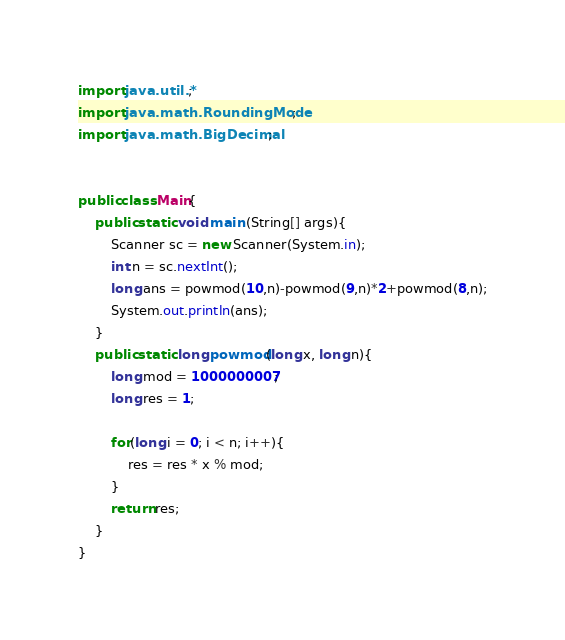Convert code to text. <code><loc_0><loc_0><loc_500><loc_500><_Java_>import java.util.*;
import java.math.RoundingMode;
import java.math.BigDecimal;
 
 
public class Main{
	public static void main (String[] args){
		Scanner sc = new Scanner(System.in);
		int n = sc.nextInt();
		long ans = powmod(10,n)-powmod(9,n)*2+powmod(8,n);
		System.out.println(ans);
	}
	public static long powmod(long x, long n){
		long mod = 1000000007;
      	long res = 1;
      
		for(long i = 0; i < n; i++){
			res = res * x % mod;
		}
		return res;
	}
}</code> 